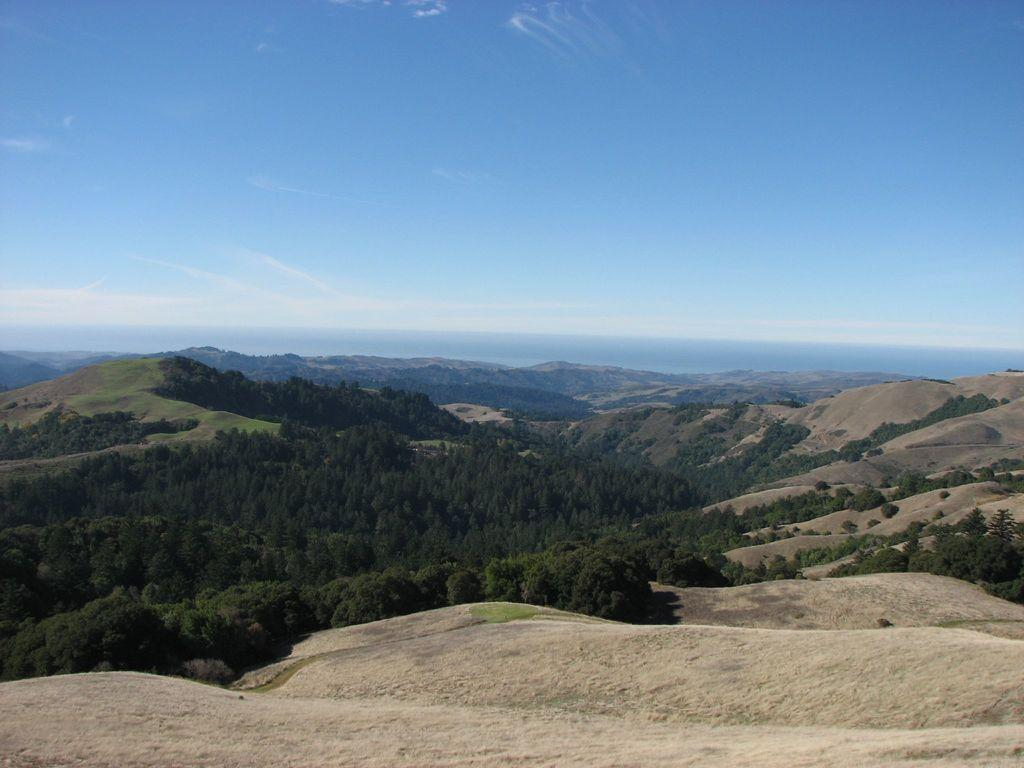What type of vegetation can be seen in the image? There are trees in the image. What geographical features are present in the image? There are hills in the image. What is visible in the background of the image? The sky is visible in the background of the image. What grade of paste is being used to paint the trees in the image? There is no indication of paint or paste being used in the image; the trees are natural vegetation. Can you see any sparks in the image? There are no sparks visible in the image. 